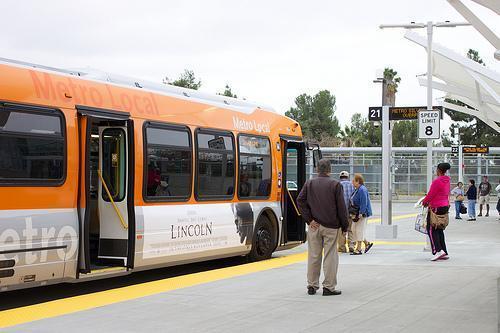How many busses are shown?
Give a very brief answer. 1. 